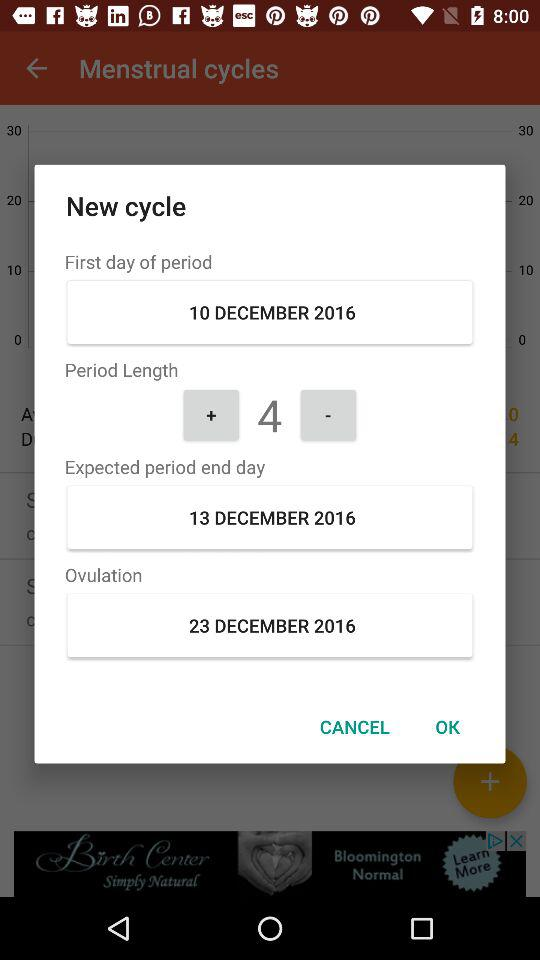What is the period length? The period length is 4. 